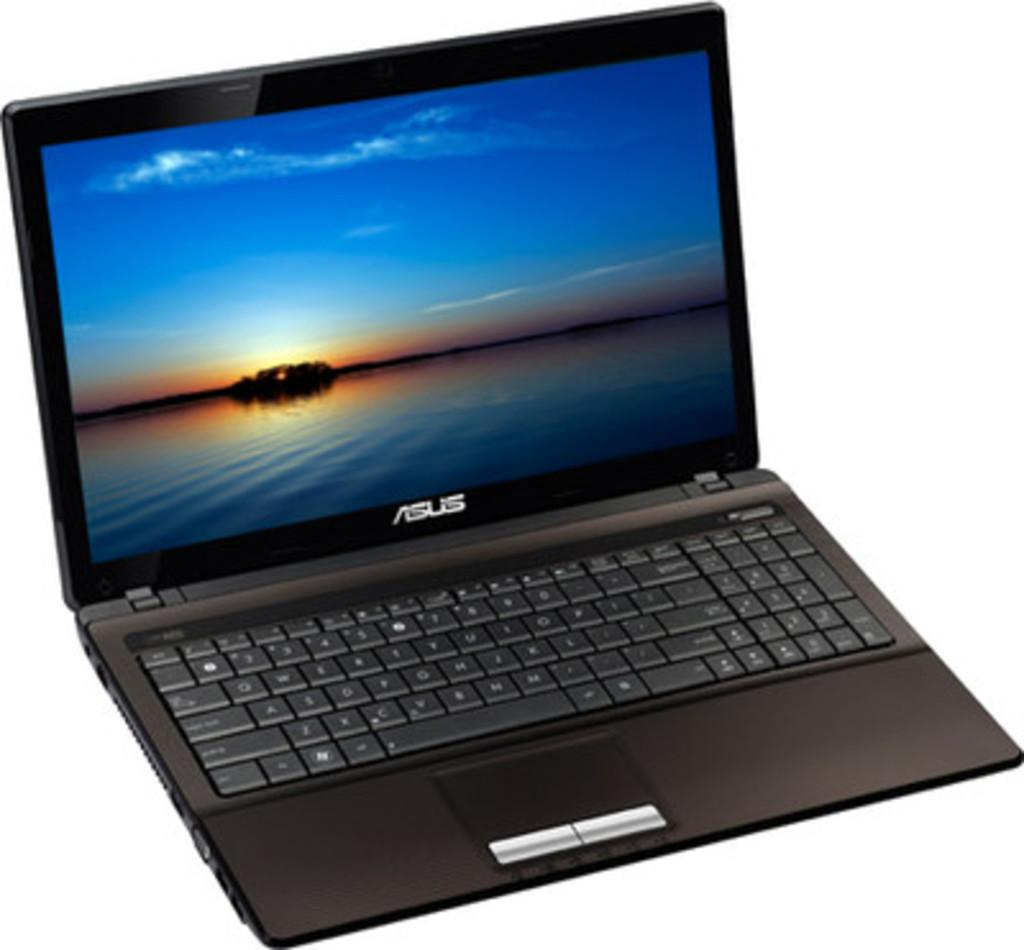Provide a one-sentence caption for the provided image. A black Asus laptop is open to a blue sky screensaver. 